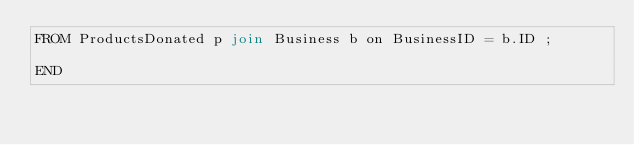<code> <loc_0><loc_0><loc_500><loc_500><_SQL_>FROM ProductsDonated p join Business b on BusinessID = b.ID ;

END</code> 